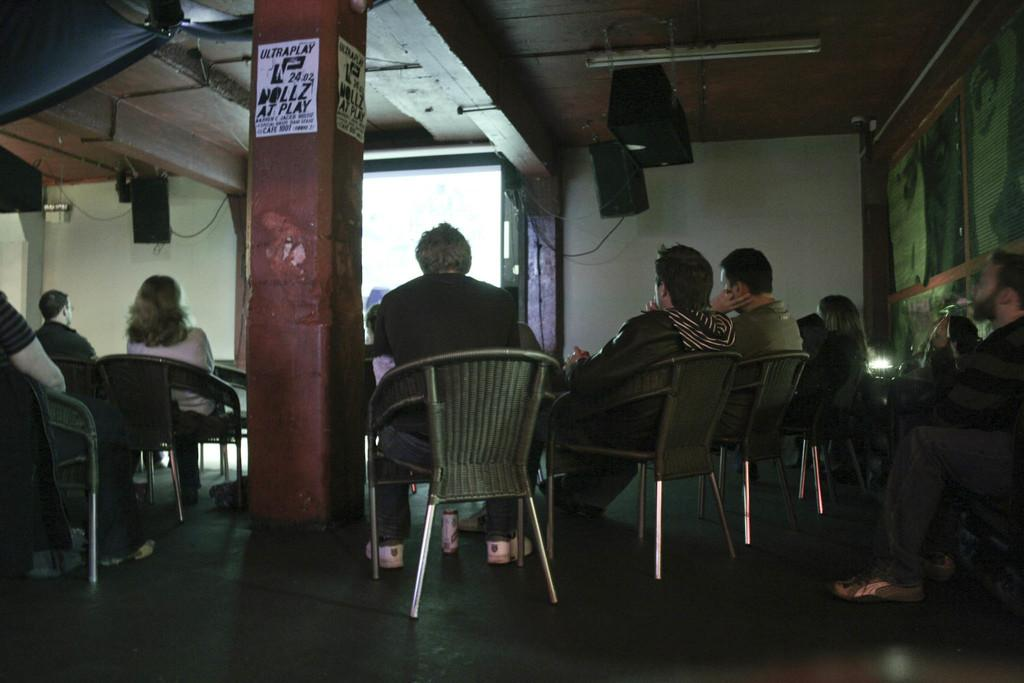What are the people in the image doing? The people in the image are sitting on chairs and looking at a screen on the wall. What can be seen in the middle of the image? There is a pillar in the middle of the image. What is happening in the background of the image? In the background, a man is playing a trumpet. What type of railway can be seen in the image? There is no railway present in the image. How many harbors are visible in the image? There are no harbors visible in the image. 